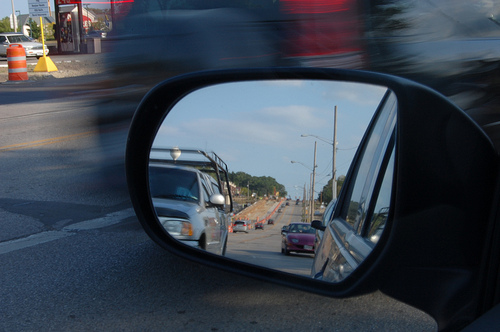<image>
Is the car in the mirror? Yes. The car is contained within or inside the mirror, showing a containment relationship. 